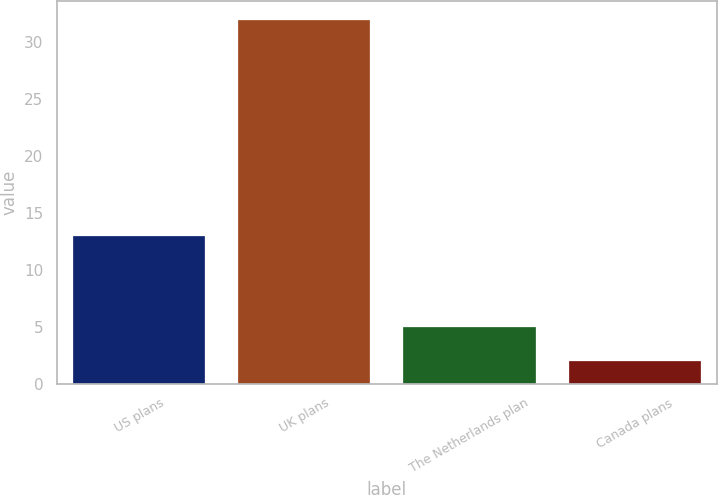Convert chart to OTSL. <chart><loc_0><loc_0><loc_500><loc_500><bar_chart><fcel>US plans<fcel>UK plans<fcel>The Netherlands plan<fcel>Canada plans<nl><fcel>13<fcel>32<fcel>5<fcel>2<nl></chart> 